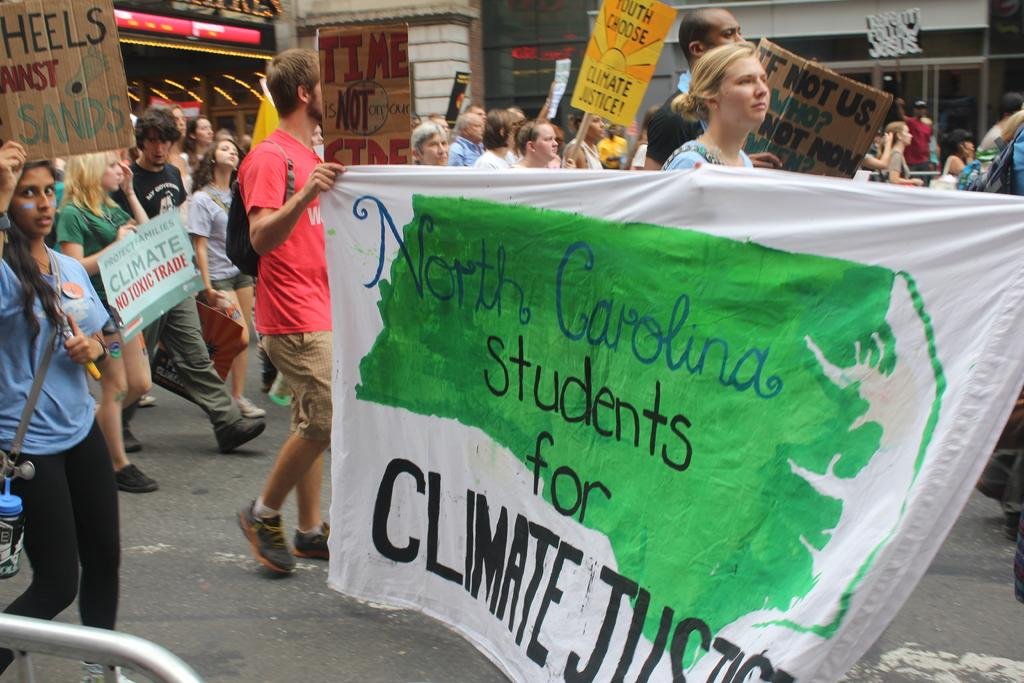How many people are present in the image? There are many people in the image. What are some people holding in the image? Some people are holding placards and banners in the image. What can be seen in the background of the image? There is a building in the background of the image. What type of pan is being used to cook food in the image? There is no pan or cooking activity present in the image. What type of fuel is being used to power the vehicles in the image? There are no vehicles present in the image. 